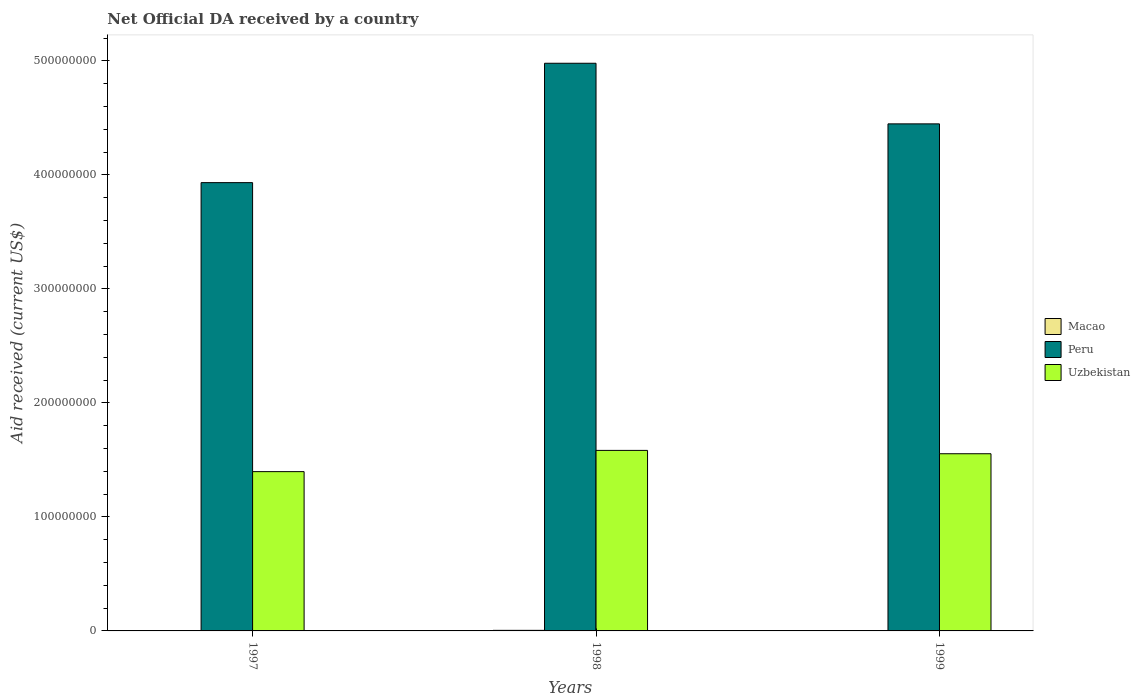How many groups of bars are there?
Make the answer very short. 3. Are the number of bars per tick equal to the number of legend labels?
Your answer should be compact. Yes. How many bars are there on the 3rd tick from the left?
Give a very brief answer. 3. How many bars are there on the 3rd tick from the right?
Your answer should be compact. 3. What is the label of the 3rd group of bars from the left?
Ensure brevity in your answer.  1999. What is the net official development assistance aid received in Uzbekistan in 1998?
Your response must be concise. 1.58e+08. Across all years, what is the maximum net official development assistance aid received in Uzbekistan?
Offer a very short reply. 1.58e+08. Across all years, what is the minimum net official development assistance aid received in Peru?
Offer a very short reply. 3.93e+08. What is the total net official development assistance aid received in Macao in the graph?
Give a very brief answer. 1.18e+06. What is the difference between the net official development assistance aid received in Macao in 1998 and that in 1999?
Your answer should be compact. 1.80e+05. What is the difference between the net official development assistance aid received in Macao in 1997 and the net official development assistance aid received in Peru in 1998?
Offer a very short reply. -4.98e+08. What is the average net official development assistance aid received in Macao per year?
Your answer should be very brief. 3.93e+05. In the year 1997, what is the difference between the net official development assistance aid received in Macao and net official development assistance aid received in Peru?
Your answer should be compact. -3.93e+08. Is the difference between the net official development assistance aid received in Macao in 1997 and 1998 greater than the difference between the net official development assistance aid received in Peru in 1997 and 1998?
Offer a terse response. Yes. What is the difference between the highest and the lowest net official development assistance aid received in Peru?
Give a very brief answer. 1.05e+08. In how many years, is the net official development assistance aid received in Macao greater than the average net official development assistance aid received in Macao taken over all years?
Your answer should be compact. 1. Is the sum of the net official development assistance aid received in Uzbekistan in 1998 and 1999 greater than the maximum net official development assistance aid received in Peru across all years?
Your answer should be very brief. No. What does the 3rd bar from the right in 1997 represents?
Your response must be concise. Macao. How many bars are there?
Offer a terse response. 9. Are all the bars in the graph horizontal?
Your response must be concise. No. What is the difference between two consecutive major ticks on the Y-axis?
Your answer should be compact. 1.00e+08. Does the graph contain any zero values?
Make the answer very short. No. Does the graph contain grids?
Offer a terse response. No. How many legend labels are there?
Your answer should be compact. 3. How are the legend labels stacked?
Make the answer very short. Vertical. What is the title of the graph?
Provide a succinct answer. Net Official DA received by a country. What is the label or title of the X-axis?
Offer a very short reply. Years. What is the label or title of the Y-axis?
Give a very brief answer. Aid received (current US$). What is the Aid received (current US$) in Peru in 1997?
Your response must be concise. 3.93e+08. What is the Aid received (current US$) of Uzbekistan in 1997?
Keep it short and to the point. 1.40e+08. What is the Aid received (current US$) in Macao in 1998?
Give a very brief answer. 5.00e+05. What is the Aid received (current US$) in Peru in 1998?
Provide a short and direct response. 4.98e+08. What is the Aid received (current US$) of Uzbekistan in 1998?
Provide a succinct answer. 1.58e+08. What is the Aid received (current US$) in Macao in 1999?
Your answer should be very brief. 3.20e+05. What is the Aid received (current US$) in Peru in 1999?
Keep it short and to the point. 4.45e+08. What is the Aid received (current US$) in Uzbekistan in 1999?
Your answer should be compact. 1.55e+08. Across all years, what is the maximum Aid received (current US$) in Macao?
Give a very brief answer. 5.00e+05. Across all years, what is the maximum Aid received (current US$) in Peru?
Provide a succinct answer. 4.98e+08. Across all years, what is the maximum Aid received (current US$) of Uzbekistan?
Provide a succinct answer. 1.58e+08. Across all years, what is the minimum Aid received (current US$) in Peru?
Your response must be concise. 3.93e+08. Across all years, what is the minimum Aid received (current US$) in Uzbekistan?
Offer a terse response. 1.40e+08. What is the total Aid received (current US$) of Macao in the graph?
Ensure brevity in your answer.  1.18e+06. What is the total Aid received (current US$) of Peru in the graph?
Your answer should be very brief. 1.34e+09. What is the total Aid received (current US$) in Uzbekistan in the graph?
Provide a short and direct response. 4.53e+08. What is the difference between the Aid received (current US$) of Macao in 1997 and that in 1998?
Ensure brevity in your answer.  -1.40e+05. What is the difference between the Aid received (current US$) of Peru in 1997 and that in 1998?
Offer a terse response. -1.05e+08. What is the difference between the Aid received (current US$) in Uzbekistan in 1997 and that in 1998?
Provide a short and direct response. -1.86e+07. What is the difference between the Aid received (current US$) in Macao in 1997 and that in 1999?
Give a very brief answer. 4.00e+04. What is the difference between the Aid received (current US$) in Peru in 1997 and that in 1999?
Your answer should be compact. -5.15e+07. What is the difference between the Aid received (current US$) in Uzbekistan in 1997 and that in 1999?
Provide a short and direct response. -1.57e+07. What is the difference between the Aid received (current US$) in Macao in 1998 and that in 1999?
Ensure brevity in your answer.  1.80e+05. What is the difference between the Aid received (current US$) of Peru in 1998 and that in 1999?
Your answer should be compact. 5.32e+07. What is the difference between the Aid received (current US$) in Uzbekistan in 1998 and that in 1999?
Your response must be concise. 2.93e+06. What is the difference between the Aid received (current US$) in Macao in 1997 and the Aid received (current US$) in Peru in 1998?
Provide a succinct answer. -4.98e+08. What is the difference between the Aid received (current US$) of Macao in 1997 and the Aid received (current US$) of Uzbekistan in 1998?
Give a very brief answer. -1.58e+08. What is the difference between the Aid received (current US$) of Peru in 1997 and the Aid received (current US$) of Uzbekistan in 1998?
Offer a terse response. 2.35e+08. What is the difference between the Aid received (current US$) of Macao in 1997 and the Aid received (current US$) of Peru in 1999?
Keep it short and to the point. -4.44e+08. What is the difference between the Aid received (current US$) in Macao in 1997 and the Aid received (current US$) in Uzbekistan in 1999?
Your response must be concise. -1.55e+08. What is the difference between the Aid received (current US$) in Peru in 1997 and the Aid received (current US$) in Uzbekistan in 1999?
Offer a terse response. 2.38e+08. What is the difference between the Aid received (current US$) in Macao in 1998 and the Aid received (current US$) in Peru in 1999?
Offer a very short reply. -4.44e+08. What is the difference between the Aid received (current US$) of Macao in 1998 and the Aid received (current US$) of Uzbekistan in 1999?
Provide a short and direct response. -1.55e+08. What is the difference between the Aid received (current US$) of Peru in 1998 and the Aid received (current US$) of Uzbekistan in 1999?
Offer a terse response. 3.42e+08. What is the average Aid received (current US$) of Macao per year?
Offer a terse response. 3.93e+05. What is the average Aid received (current US$) in Peru per year?
Keep it short and to the point. 4.45e+08. What is the average Aid received (current US$) of Uzbekistan per year?
Provide a succinct answer. 1.51e+08. In the year 1997, what is the difference between the Aid received (current US$) of Macao and Aid received (current US$) of Peru?
Your response must be concise. -3.93e+08. In the year 1997, what is the difference between the Aid received (current US$) of Macao and Aid received (current US$) of Uzbekistan?
Ensure brevity in your answer.  -1.39e+08. In the year 1997, what is the difference between the Aid received (current US$) of Peru and Aid received (current US$) of Uzbekistan?
Your response must be concise. 2.53e+08. In the year 1998, what is the difference between the Aid received (current US$) of Macao and Aid received (current US$) of Peru?
Keep it short and to the point. -4.97e+08. In the year 1998, what is the difference between the Aid received (current US$) of Macao and Aid received (current US$) of Uzbekistan?
Ensure brevity in your answer.  -1.58e+08. In the year 1998, what is the difference between the Aid received (current US$) of Peru and Aid received (current US$) of Uzbekistan?
Give a very brief answer. 3.40e+08. In the year 1999, what is the difference between the Aid received (current US$) in Macao and Aid received (current US$) in Peru?
Your answer should be compact. -4.44e+08. In the year 1999, what is the difference between the Aid received (current US$) of Macao and Aid received (current US$) of Uzbekistan?
Make the answer very short. -1.55e+08. In the year 1999, what is the difference between the Aid received (current US$) of Peru and Aid received (current US$) of Uzbekistan?
Make the answer very short. 2.89e+08. What is the ratio of the Aid received (current US$) of Macao in 1997 to that in 1998?
Offer a very short reply. 0.72. What is the ratio of the Aid received (current US$) in Peru in 1997 to that in 1998?
Offer a very short reply. 0.79. What is the ratio of the Aid received (current US$) in Uzbekistan in 1997 to that in 1998?
Your answer should be very brief. 0.88. What is the ratio of the Aid received (current US$) in Peru in 1997 to that in 1999?
Ensure brevity in your answer.  0.88. What is the ratio of the Aid received (current US$) of Uzbekistan in 1997 to that in 1999?
Offer a terse response. 0.9. What is the ratio of the Aid received (current US$) of Macao in 1998 to that in 1999?
Give a very brief answer. 1.56. What is the ratio of the Aid received (current US$) in Peru in 1998 to that in 1999?
Provide a short and direct response. 1.12. What is the ratio of the Aid received (current US$) of Uzbekistan in 1998 to that in 1999?
Ensure brevity in your answer.  1.02. What is the difference between the highest and the second highest Aid received (current US$) in Peru?
Provide a succinct answer. 5.32e+07. What is the difference between the highest and the second highest Aid received (current US$) in Uzbekistan?
Provide a short and direct response. 2.93e+06. What is the difference between the highest and the lowest Aid received (current US$) of Macao?
Give a very brief answer. 1.80e+05. What is the difference between the highest and the lowest Aid received (current US$) of Peru?
Give a very brief answer. 1.05e+08. What is the difference between the highest and the lowest Aid received (current US$) in Uzbekistan?
Keep it short and to the point. 1.86e+07. 